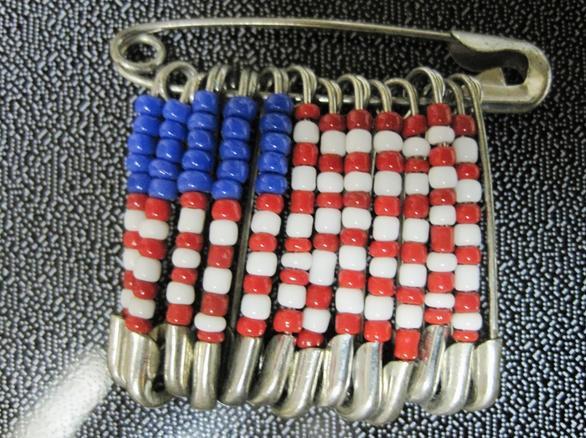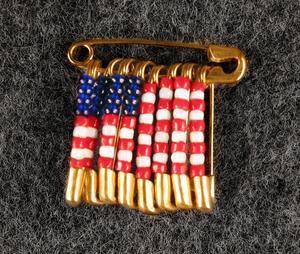The first image is the image on the left, the second image is the image on the right. Considering the images on both sides, is "At least one image shows pins with beads forming an American flag pattern." valid? Answer yes or no. Yes. 